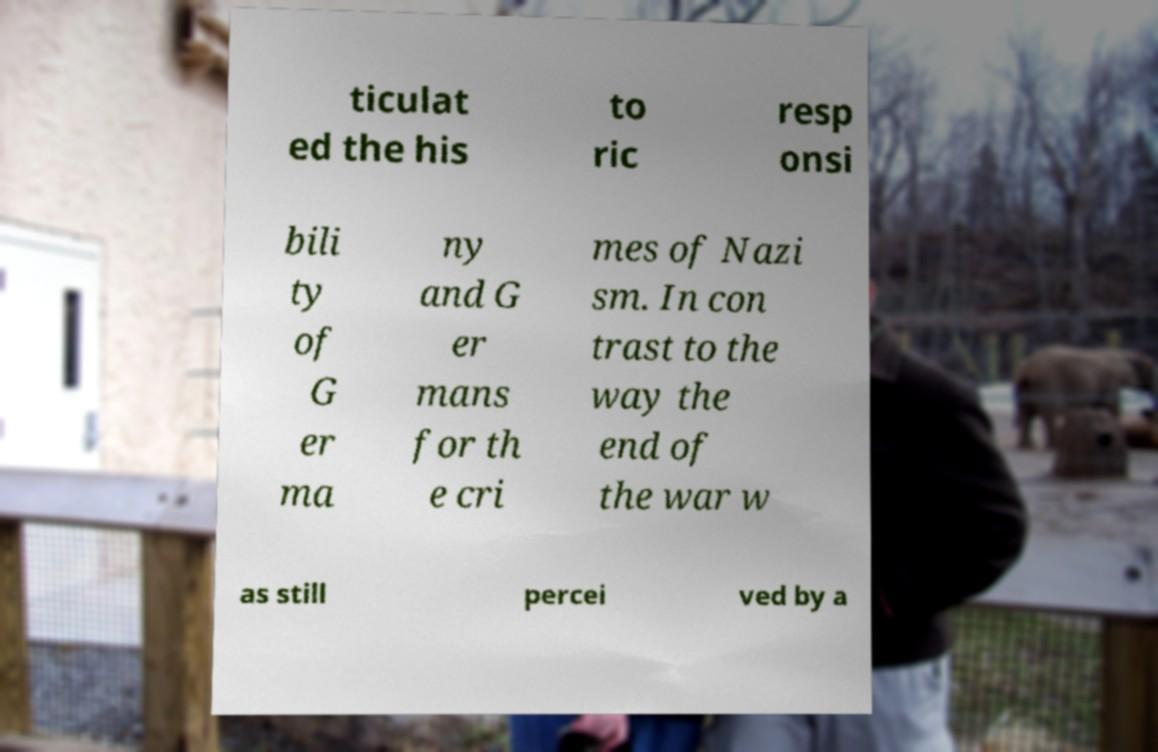Could you assist in decoding the text presented in this image and type it out clearly? ticulat ed the his to ric resp onsi bili ty of G er ma ny and G er mans for th e cri mes of Nazi sm. In con trast to the way the end of the war w as still percei ved by a 